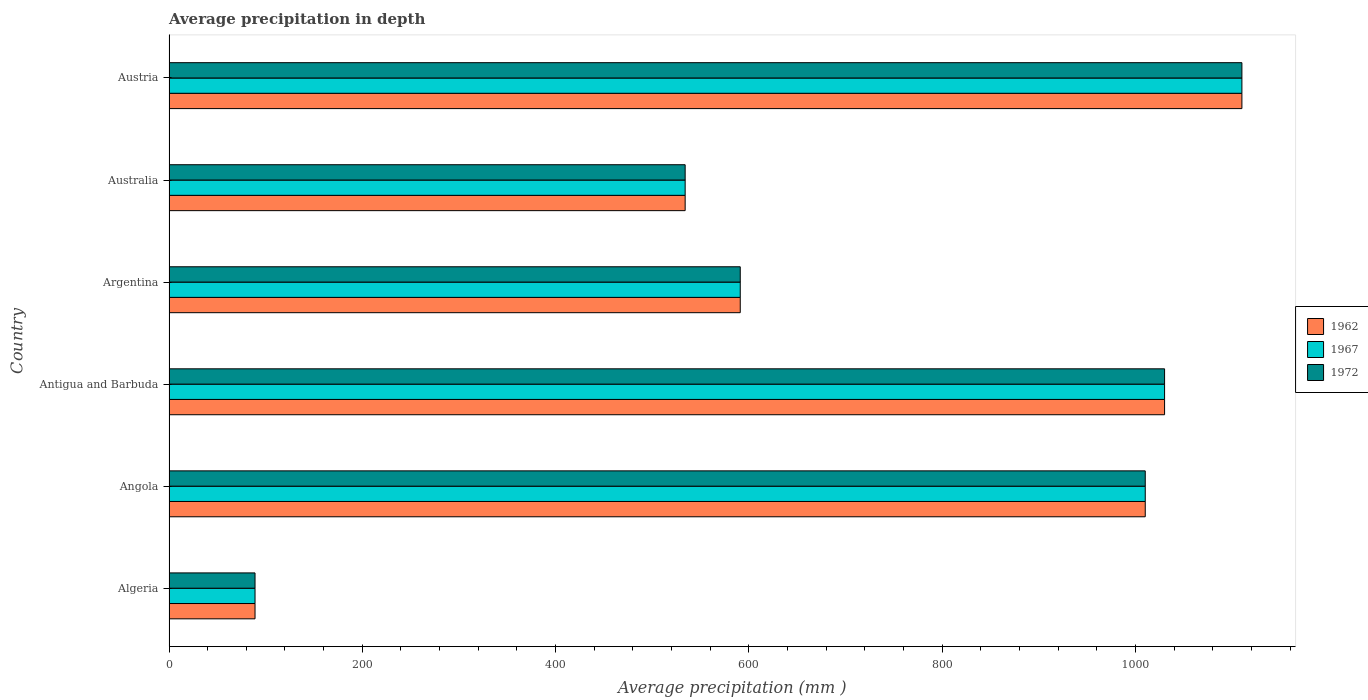What is the label of the 6th group of bars from the top?
Offer a very short reply. Algeria. In how many cases, is the number of bars for a given country not equal to the number of legend labels?
Make the answer very short. 0. What is the average precipitation in 1967 in Angola?
Ensure brevity in your answer.  1010. Across all countries, what is the maximum average precipitation in 1972?
Offer a very short reply. 1110. Across all countries, what is the minimum average precipitation in 1967?
Provide a short and direct response. 89. In which country was the average precipitation in 1972 maximum?
Provide a short and direct response. Austria. In which country was the average precipitation in 1962 minimum?
Provide a succinct answer. Algeria. What is the total average precipitation in 1962 in the graph?
Ensure brevity in your answer.  4364. What is the difference between the average precipitation in 1972 in Angola and that in Antigua and Barbuda?
Offer a very short reply. -20. What is the difference between the average precipitation in 1972 in Angola and the average precipitation in 1967 in Australia?
Keep it short and to the point. 476. What is the average average precipitation in 1962 per country?
Your answer should be very brief. 727.33. In how many countries, is the average precipitation in 1972 greater than 680 mm?
Offer a terse response. 3. What is the ratio of the average precipitation in 1962 in Angola to that in Antigua and Barbuda?
Your answer should be very brief. 0.98. Is the difference between the average precipitation in 1967 in Antigua and Barbuda and Austria greater than the difference between the average precipitation in 1972 in Antigua and Barbuda and Austria?
Make the answer very short. No. What is the difference between the highest and the second highest average precipitation in 1962?
Your answer should be compact. 80. What is the difference between the highest and the lowest average precipitation in 1962?
Make the answer very short. 1021. In how many countries, is the average precipitation in 1962 greater than the average average precipitation in 1962 taken over all countries?
Provide a short and direct response. 3. What does the 2nd bar from the top in Austria represents?
Give a very brief answer. 1967. How many bars are there?
Keep it short and to the point. 18. How many countries are there in the graph?
Your answer should be compact. 6. Are the values on the major ticks of X-axis written in scientific E-notation?
Your response must be concise. No. Where does the legend appear in the graph?
Keep it short and to the point. Center right. What is the title of the graph?
Keep it short and to the point. Average precipitation in depth. What is the label or title of the X-axis?
Provide a succinct answer. Average precipitation (mm ). What is the label or title of the Y-axis?
Make the answer very short. Country. What is the Average precipitation (mm ) in 1962 in Algeria?
Your response must be concise. 89. What is the Average precipitation (mm ) of 1967 in Algeria?
Ensure brevity in your answer.  89. What is the Average precipitation (mm ) in 1972 in Algeria?
Offer a very short reply. 89. What is the Average precipitation (mm ) in 1962 in Angola?
Your answer should be compact. 1010. What is the Average precipitation (mm ) in 1967 in Angola?
Make the answer very short. 1010. What is the Average precipitation (mm ) of 1972 in Angola?
Your response must be concise. 1010. What is the Average precipitation (mm ) in 1962 in Antigua and Barbuda?
Your answer should be compact. 1030. What is the Average precipitation (mm ) in 1967 in Antigua and Barbuda?
Offer a very short reply. 1030. What is the Average precipitation (mm ) of 1972 in Antigua and Barbuda?
Your answer should be very brief. 1030. What is the Average precipitation (mm ) in 1962 in Argentina?
Your answer should be compact. 591. What is the Average precipitation (mm ) of 1967 in Argentina?
Your answer should be compact. 591. What is the Average precipitation (mm ) of 1972 in Argentina?
Offer a very short reply. 591. What is the Average precipitation (mm ) in 1962 in Australia?
Give a very brief answer. 534. What is the Average precipitation (mm ) of 1967 in Australia?
Your answer should be compact. 534. What is the Average precipitation (mm ) of 1972 in Australia?
Your response must be concise. 534. What is the Average precipitation (mm ) of 1962 in Austria?
Your response must be concise. 1110. What is the Average precipitation (mm ) of 1967 in Austria?
Give a very brief answer. 1110. What is the Average precipitation (mm ) in 1972 in Austria?
Offer a very short reply. 1110. Across all countries, what is the maximum Average precipitation (mm ) of 1962?
Make the answer very short. 1110. Across all countries, what is the maximum Average precipitation (mm ) in 1967?
Your response must be concise. 1110. Across all countries, what is the maximum Average precipitation (mm ) of 1972?
Your answer should be very brief. 1110. Across all countries, what is the minimum Average precipitation (mm ) of 1962?
Your answer should be compact. 89. Across all countries, what is the minimum Average precipitation (mm ) in 1967?
Offer a terse response. 89. Across all countries, what is the minimum Average precipitation (mm ) of 1972?
Provide a succinct answer. 89. What is the total Average precipitation (mm ) of 1962 in the graph?
Make the answer very short. 4364. What is the total Average precipitation (mm ) in 1967 in the graph?
Give a very brief answer. 4364. What is the total Average precipitation (mm ) of 1972 in the graph?
Provide a succinct answer. 4364. What is the difference between the Average precipitation (mm ) of 1962 in Algeria and that in Angola?
Make the answer very short. -921. What is the difference between the Average precipitation (mm ) of 1967 in Algeria and that in Angola?
Your answer should be compact. -921. What is the difference between the Average precipitation (mm ) of 1972 in Algeria and that in Angola?
Keep it short and to the point. -921. What is the difference between the Average precipitation (mm ) of 1962 in Algeria and that in Antigua and Barbuda?
Ensure brevity in your answer.  -941. What is the difference between the Average precipitation (mm ) in 1967 in Algeria and that in Antigua and Barbuda?
Your answer should be very brief. -941. What is the difference between the Average precipitation (mm ) of 1972 in Algeria and that in Antigua and Barbuda?
Give a very brief answer. -941. What is the difference between the Average precipitation (mm ) in 1962 in Algeria and that in Argentina?
Offer a terse response. -502. What is the difference between the Average precipitation (mm ) of 1967 in Algeria and that in Argentina?
Offer a very short reply. -502. What is the difference between the Average precipitation (mm ) of 1972 in Algeria and that in Argentina?
Your answer should be very brief. -502. What is the difference between the Average precipitation (mm ) in 1962 in Algeria and that in Australia?
Keep it short and to the point. -445. What is the difference between the Average precipitation (mm ) in 1967 in Algeria and that in Australia?
Ensure brevity in your answer.  -445. What is the difference between the Average precipitation (mm ) in 1972 in Algeria and that in Australia?
Give a very brief answer. -445. What is the difference between the Average precipitation (mm ) in 1962 in Algeria and that in Austria?
Make the answer very short. -1021. What is the difference between the Average precipitation (mm ) in 1967 in Algeria and that in Austria?
Provide a short and direct response. -1021. What is the difference between the Average precipitation (mm ) of 1972 in Algeria and that in Austria?
Your answer should be compact. -1021. What is the difference between the Average precipitation (mm ) in 1967 in Angola and that in Antigua and Barbuda?
Provide a succinct answer. -20. What is the difference between the Average precipitation (mm ) in 1962 in Angola and that in Argentina?
Offer a very short reply. 419. What is the difference between the Average precipitation (mm ) of 1967 in Angola and that in Argentina?
Your answer should be very brief. 419. What is the difference between the Average precipitation (mm ) in 1972 in Angola and that in Argentina?
Provide a succinct answer. 419. What is the difference between the Average precipitation (mm ) in 1962 in Angola and that in Australia?
Your answer should be compact. 476. What is the difference between the Average precipitation (mm ) in 1967 in Angola and that in Australia?
Offer a very short reply. 476. What is the difference between the Average precipitation (mm ) of 1972 in Angola and that in Australia?
Make the answer very short. 476. What is the difference between the Average precipitation (mm ) in 1962 in Angola and that in Austria?
Your answer should be compact. -100. What is the difference between the Average precipitation (mm ) of 1967 in Angola and that in Austria?
Offer a very short reply. -100. What is the difference between the Average precipitation (mm ) in 1972 in Angola and that in Austria?
Make the answer very short. -100. What is the difference between the Average precipitation (mm ) of 1962 in Antigua and Barbuda and that in Argentina?
Offer a terse response. 439. What is the difference between the Average precipitation (mm ) in 1967 in Antigua and Barbuda and that in Argentina?
Give a very brief answer. 439. What is the difference between the Average precipitation (mm ) in 1972 in Antigua and Barbuda and that in Argentina?
Give a very brief answer. 439. What is the difference between the Average precipitation (mm ) in 1962 in Antigua and Barbuda and that in Australia?
Offer a very short reply. 496. What is the difference between the Average precipitation (mm ) in 1967 in Antigua and Barbuda and that in Australia?
Your answer should be very brief. 496. What is the difference between the Average precipitation (mm ) in 1972 in Antigua and Barbuda and that in Australia?
Make the answer very short. 496. What is the difference between the Average precipitation (mm ) in 1962 in Antigua and Barbuda and that in Austria?
Provide a succinct answer. -80. What is the difference between the Average precipitation (mm ) in 1967 in Antigua and Barbuda and that in Austria?
Provide a short and direct response. -80. What is the difference between the Average precipitation (mm ) in 1972 in Antigua and Barbuda and that in Austria?
Your answer should be compact. -80. What is the difference between the Average precipitation (mm ) of 1972 in Argentina and that in Australia?
Offer a very short reply. 57. What is the difference between the Average precipitation (mm ) of 1962 in Argentina and that in Austria?
Provide a short and direct response. -519. What is the difference between the Average precipitation (mm ) in 1967 in Argentina and that in Austria?
Ensure brevity in your answer.  -519. What is the difference between the Average precipitation (mm ) of 1972 in Argentina and that in Austria?
Give a very brief answer. -519. What is the difference between the Average precipitation (mm ) of 1962 in Australia and that in Austria?
Ensure brevity in your answer.  -576. What is the difference between the Average precipitation (mm ) in 1967 in Australia and that in Austria?
Offer a terse response. -576. What is the difference between the Average precipitation (mm ) of 1972 in Australia and that in Austria?
Provide a succinct answer. -576. What is the difference between the Average precipitation (mm ) of 1962 in Algeria and the Average precipitation (mm ) of 1967 in Angola?
Offer a terse response. -921. What is the difference between the Average precipitation (mm ) of 1962 in Algeria and the Average precipitation (mm ) of 1972 in Angola?
Ensure brevity in your answer.  -921. What is the difference between the Average precipitation (mm ) of 1967 in Algeria and the Average precipitation (mm ) of 1972 in Angola?
Offer a terse response. -921. What is the difference between the Average precipitation (mm ) of 1962 in Algeria and the Average precipitation (mm ) of 1967 in Antigua and Barbuda?
Give a very brief answer. -941. What is the difference between the Average precipitation (mm ) in 1962 in Algeria and the Average precipitation (mm ) in 1972 in Antigua and Barbuda?
Ensure brevity in your answer.  -941. What is the difference between the Average precipitation (mm ) of 1967 in Algeria and the Average precipitation (mm ) of 1972 in Antigua and Barbuda?
Provide a short and direct response. -941. What is the difference between the Average precipitation (mm ) of 1962 in Algeria and the Average precipitation (mm ) of 1967 in Argentina?
Provide a short and direct response. -502. What is the difference between the Average precipitation (mm ) in 1962 in Algeria and the Average precipitation (mm ) in 1972 in Argentina?
Make the answer very short. -502. What is the difference between the Average precipitation (mm ) of 1967 in Algeria and the Average precipitation (mm ) of 1972 in Argentina?
Your response must be concise. -502. What is the difference between the Average precipitation (mm ) in 1962 in Algeria and the Average precipitation (mm ) in 1967 in Australia?
Your answer should be very brief. -445. What is the difference between the Average precipitation (mm ) of 1962 in Algeria and the Average precipitation (mm ) of 1972 in Australia?
Offer a very short reply. -445. What is the difference between the Average precipitation (mm ) in 1967 in Algeria and the Average precipitation (mm ) in 1972 in Australia?
Ensure brevity in your answer.  -445. What is the difference between the Average precipitation (mm ) of 1962 in Algeria and the Average precipitation (mm ) of 1967 in Austria?
Provide a succinct answer. -1021. What is the difference between the Average precipitation (mm ) of 1962 in Algeria and the Average precipitation (mm ) of 1972 in Austria?
Your answer should be compact. -1021. What is the difference between the Average precipitation (mm ) in 1967 in Algeria and the Average precipitation (mm ) in 1972 in Austria?
Your answer should be very brief. -1021. What is the difference between the Average precipitation (mm ) in 1962 in Angola and the Average precipitation (mm ) in 1967 in Antigua and Barbuda?
Offer a very short reply. -20. What is the difference between the Average precipitation (mm ) of 1962 in Angola and the Average precipitation (mm ) of 1972 in Antigua and Barbuda?
Your answer should be compact. -20. What is the difference between the Average precipitation (mm ) of 1962 in Angola and the Average precipitation (mm ) of 1967 in Argentina?
Your answer should be compact. 419. What is the difference between the Average precipitation (mm ) in 1962 in Angola and the Average precipitation (mm ) in 1972 in Argentina?
Keep it short and to the point. 419. What is the difference between the Average precipitation (mm ) of 1967 in Angola and the Average precipitation (mm ) of 1972 in Argentina?
Provide a succinct answer. 419. What is the difference between the Average precipitation (mm ) in 1962 in Angola and the Average precipitation (mm ) in 1967 in Australia?
Offer a very short reply. 476. What is the difference between the Average precipitation (mm ) of 1962 in Angola and the Average precipitation (mm ) of 1972 in Australia?
Your answer should be compact. 476. What is the difference between the Average precipitation (mm ) of 1967 in Angola and the Average precipitation (mm ) of 1972 in Australia?
Give a very brief answer. 476. What is the difference between the Average precipitation (mm ) of 1962 in Angola and the Average precipitation (mm ) of 1967 in Austria?
Ensure brevity in your answer.  -100. What is the difference between the Average precipitation (mm ) in 1962 in Angola and the Average precipitation (mm ) in 1972 in Austria?
Provide a succinct answer. -100. What is the difference between the Average precipitation (mm ) in 1967 in Angola and the Average precipitation (mm ) in 1972 in Austria?
Make the answer very short. -100. What is the difference between the Average precipitation (mm ) in 1962 in Antigua and Barbuda and the Average precipitation (mm ) in 1967 in Argentina?
Offer a very short reply. 439. What is the difference between the Average precipitation (mm ) of 1962 in Antigua and Barbuda and the Average precipitation (mm ) of 1972 in Argentina?
Make the answer very short. 439. What is the difference between the Average precipitation (mm ) of 1967 in Antigua and Barbuda and the Average precipitation (mm ) of 1972 in Argentina?
Your answer should be compact. 439. What is the difference between the Average precipitation (mm ) of 1962 in Antigua and Barbuda and the Average precipitation (mm ) of 1967 in Australia?
Offer a terse response. 496. What is the difference between the Average precipitation (mm ) in 1962 in Antigua and Barbuda and the Average precipitation (mm ) in 1972 in Australia?
Ensure brevity in your answer.  496. What is the difference between the Average precipitation (mm ) of 1967 in Antigua and Barbuda and the Average precipitation (mm ) of 1972 in Australia?
Offer a very short reply. 496. What is the difference between the Average precipitation (mm ) of 1962 in Antigua and Barbuda and the Average precipitation (mm ) of 1967 in Austria?
Give a very brief answer. -80. What is the difference between the Average precipitation (mm ) in 1962 in Antigua and Barbuda and the Average precipitation (mm ) in 1972 in Austria?
Your answer should be very brief. -80. What is the difference between the Average precipitation (mm ) in 1967 in Antigua and Barbuda and the Average precipitation (mm ) in 1972 in Austria?
Your answer should be very brief. -80. What is the difference between the Average precipitation (mm ) in 1962 in Argentina and the Average precipitation (mm ) in 1967 in Australia?
Keep it short and to the point. 57. What is the difference between the Average precipitation (mm ) of 1962 in Argentina and the Average precipitation (mm ) of 1967 in Austria?
Ensure brevity in your answer.  -519. What is the difference between the Average precipitation (mm ) of 1962 in Argentina and the Average precipitation (mm ) of 1972 in Austria?
Ensure brevity in your answer.  -519. What is the difference between the Average precipitation (mm ) of 1967 in Argentina and the Average precipitation (mm ) of 1972 in Austria?
Offer a terse response. -519. What is the difference between the Average precipitation (mm ) in 1962 in Australia and the Average precipitation (mm ) in 1967 in Austria?
Keep it short and to the point. -576. What is the difference between the Average precipitation (mm ) in 1962 in Australia and the Average precipitation (mm ) in 1972 in Austria?
Provide a succinct answer. -576. What is the difference between the Average precipitation (mm ) of 1967 in Australia and the Average precipitation (mm ) of 1972 in Austria?
Ensure brevity in your answer.  -576. What is the average Average precipitation (mm ) in 1962 per country?
Make the answer very short. 727.33. What is the average Average precipitation (mm ) of 1967 per country?
Offer a terse response. 727.33. What is the average Average precipitation (mm ) of 1972 per country?
Offer a very short reply. 727.33. What is the difference between the Average precipitation (mm ) in 1962 and Average precipitation (mm ) in 1972 in Algeria?
Offer a very short reply. 0. What is the difference between the Average precipitation (mm ) of 1967 and Average precipitation (mm ) of 1972 in Algeria?
Keep it short and to the point. 0. What is the difference between the Average precipitation (mm ) of 1962 and Average precipitation (mm ) of 1972 in Angola?
Make the answer very short. 0. What is the difference between the Average precipitation (mm ) of 1967 and Average precipitation (mm ) of 1972 in Angola?
Keep it short and to the point. 0. What is the difference between the Average precipitation (mm ) of 1962 and Average precipitation (mm ) of 1972 in Antigua and Barbuda?
Provide a short and direct response. 0. What is the difference between the Average precipitation (mm ) of 1967 and Average precipitation (mm ) of 1972 in Antigua and Barbuda?
Offer a terse response. 0. What is the difference between the Average precipitation (mm ) in 1962 and Average precipitation (mm ) in 1967 in Argentina?
Your answer should be compact. 0. What is the difference between the Average precipitation (mm ) in 1962 and Average precipitation (mm ) in 1972 in Argentina?
Keep it short and to the point. 0. What is the difference between the Average precipitation (mm ) of 1962 and Average precipitation (mm ) of 1967 in Australia?
Your answer should be compact. 0. What is the difference between the Average precipitation (mm ) in 1967 and Average precipitation (mm ) in 1972 in Australia?
Offer a very short reply. 0. What is the difference between the Average precipitation (mm ) of 1962 and Average precipitation (mm ) of 1967 in Austria?
Keep it short and to the point. 0. What is the ratio of the Average precipitation (mm ) in 1962 in Algeria to that in Angola?
Give a very brief answer. 0.09. What is the ratio of the Average precipitation (mm ) of 1967 in Algeria to that in Angola?
Give a very brief answer. 0.09. What is the ratio of the Average precipitation (mm ) of 1972 in Algeria to that in Angola?
Offer a terse response. 0.09. What is the ratio of the Average precipitation (mm ) of 1962 in Algeria to that in Antigua and Barbuda?
Ensure brevity in your answer.  0.09. What is the ratio of the Average precipitation (mm ) in 1967 in Algeria to that in Antigua and Barbuda?
Your response must be concise. 0.09. What is the ratio of the Average precipitation (mm ) in 1972 in Algeria to that in Antigua and Barbuda?
Give a very brief answer. 0.09. What is the ratio of the Average precipitation (mm ) in 1962 in Algeria to that in Argentina?
Make the answer very short. 0.15. What is the ratio of the Average precipitation (mm ) of 1967 in Algeria to that in Argentina?
Provide a short and direct response. 0.15. What is the ratio of the Average precipitation (mm ) in 1972 in Algeria to that in Argentina?
Offer a very short reply. 0.15. What is the ratio of the Average precipitation (mm ) in 1972 in Algeria to that in Australia?
Your response must be concise. 0.17. What is the ratio of the Average precipitation (mm ) of 1962 in Algeria to that in Austria?
Ensure brevity in your answer.  0.08. What is the ratio of the Average precipitation (mm ) of 1967 in Algeria to that in Austria?
Keep it short and to the point. 0.08. What is the ratio of the Average precipitation (mm ) in 1972 in Algeria to that in Austria?
Offer a very short reply. 0.08. What is the ratio of the Average precipitation (mm ) of 1962 in Angola to that in Antigua and Barbuda?
Provide a short and direct response. 0.98. What is the ratio of the Average precipitation (mm ) of 1967 in Angola to that in Antigua and Barbuda?
Give a very brief answer. 0.98. What is the ratio of the Average precipitation (mm ) of 1972 in Angola to that in Antigua and Barbuda?
Offer a terse response. 0.98. What is the ratio of the Average precipitation (mm ) in 1962 in Angola to that in Argentina?
Your answer should be compact. 1.71. What is the ratio of the Average precipitation (mm ) of 1967 in Angola to that in Argentina?
Ensure brevity in your answer.  1.71. What is the ratio of the Average precipitation (mm ) of 1972 in Angola to that in Argentina?
Offer a very short reply. 1.71. What is the ratio of the Average precipitation (mm ) of 1962 in Angola to that in Australia?
Your answer should be very brief. 1.89. What is the ratio of the Average precipitation (mm ) of 1967 in Angola to that in Australia?
Ensure brevity in your answer.  1.89. What is the ratio of the Average precipitation (mm ) of 1972 in Angola to that in Australia?
Your answer should be very brief. 1.89. What is the ratio of the Average precipitation (mm ) of 1962 in Angola to that in Austria?
Keep it short and to the point. 0.91. What is the ratio of the Average precipitation (mm ) of 1967 in Angola to that in Austria?
Give a very brief answer. 0.91. What is the ratio of the Average precipitation (mm ) in 1972 in Angola to that in Austria?
Keep it short and to the point. 0.91. What is the ratio of the Average precipitation (mm ) in 1962 in Antigua and Barbuda to that in Argentina?
Offer a terse response. 1.74. What is the ratio of the Average precipitation (mm ) of 1967 in Antigua and Barbuda to that in Argentina?
Provide a short and direct response. 1.74. What is the ratio of the Average precipitation (mm ) of 1972 in Antigua and Barbuda to that in Argentina?
Your answer should be very brief. 1.74. What is the ratio of the Average precipitation (mm ) of 1962 in Antigua and Barbuda to that in Australia?
Your answer should be compact. 1.93. What is the ratio of the Average precipitation (mm ) of 1967 in Antigua and Barbuda to that in Australia?
Your response must be concise. 1.93. What is the ratio of the Average precipitation (mm ) of 1972 in Antigua and Barbuda to that in Australia?
Keep it short and to the point. 1.93. What is the ratio of the Average precipitation (mm ) in 1962 in Antigua and Barbuda to that in Austria?
Your response must be concise. 0.93. What is the ratio of the Average precipitation (mm ) of 1967 in Antigua and Barbuda to that in Austria?
Provide a succinct answer. 0.93. What is the ratio of the Average precipitation (mm ) of 1972 in Antigua and Barbuda to that in Austria?
Your response must be concise. 0.93. What is the ratio of the Average precipitation (mm ) of 1962 in Argentina to that in Australia?
Your answer should be compact. 1.11. What is the ratio of the Average precipitation (mm ) of 1967 in Argentina to that in Australia?
Keep it short and to the point. 1.11. What is the ratio of the Average precipitation (mm ) of 1972 in Argentina to that in Australia?
Provide a succinct answer. 1.11. What is the ratio of the Average precipitation (mm ) of 1962 in Argentina to that in Austria?
Give a very brief answer. 0.53. What is the ratio of the Average precipitation (mm ) of 1967 in Argentina to that in Austria?
Offer a terse response. 0.53. What is the ratio of the Average precipitation (mm ) of 1972 in Argentina to that in Austria?
Your answer should be compact. 0.53. What is the ratio of the Average precipitation (mm ) in 1962 in Australia to that in Austria?
Keep it short and to the point. 0.48. What is the ratio of the Average precipitation (mm ) of 1967 in Australia to that in Austria?
Provide a succinct answer. 0.48. What is the ratio of the Average precipitation (mm ) in 1972 in Australia to that in Austria?
Your answer should be very brief. 0.48. What is the difference between the highest and the second highest Average precipitation (mm ) in 1962?
Provide a short and direct response. 80. What is the difference between the highest and the lowest Average precipitation (mm ) of 1962?
Offer a terse response. 1021. What is the difference between the highest and the lowest Average precipitation (mm ) of 1967?
Offer a very short reply. 1021. What is the difference between the highest and the lowest Average precipitation (mm ) of 1972?
Keep it short and to the point. 1021. 